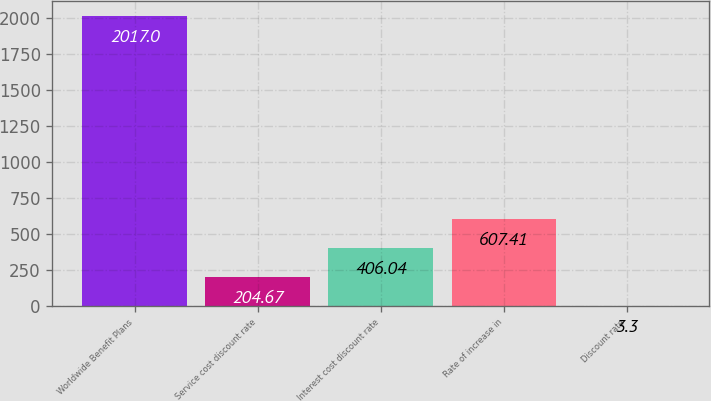Convert chart to OTSL. <chart><loc_0><loc_0><loc_500><loc_500><bar_chart><fcel>Worldwide Benefit Plans<fcel>Service cost discount rate<fcel>Interest cost discount rate<fcel>Rate of increase in<fcel>Discount rate<nl><fcel>2017<fcel>204.67<fcel>406.04<fcel>607.41<fcel>3.3<nl></chart> 